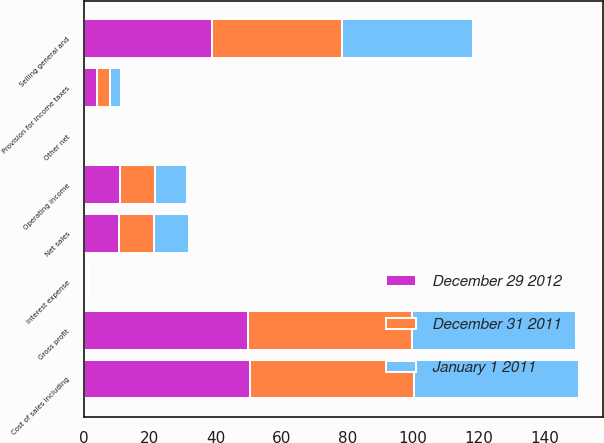Convert chart to OTSL. <chart><loc_0><loc_0><loc_500><loc_500><stacked_bar_chart><ecel><fcel>Net sales<fcel>Cost of sales including<fcel>Gross profit<fcel>Selling general and<fcel>Operating income<fcel>Interest expense<fcel>Other net<fcel>Provision for income taxes<nl><fcel>December 31 2011<fcel>10.6<fcel>50.1<fcel>49.9<fcel>39.3<fcel>10.6<fcel>0.5<fcel>0<fcel>3.8<nl><fcel>December 29 2012<fcel>10.6<fcel>50.3<fcel>49.7<fcel>39<fcel>10.8<fcel>0.5<fcel>0<fcel>3.9<nl><fcel>January 1 2011<fcel>10.6<fcel>50<fcel>50<fcel>40.1<fcel>9.9<fcel>0.5<fcel>0<fcel>3.6<nl></chart> 